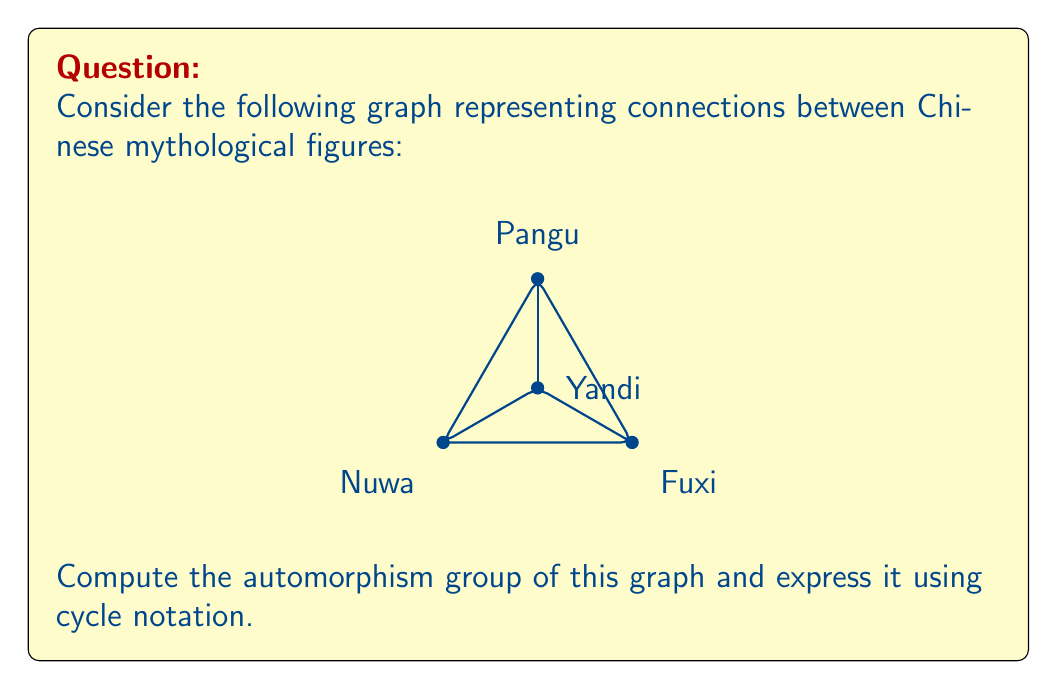Can you answer this question? To find the automorphisms of this graph, we need to identify the permutations of vertices that preserve the edge structure. Let's approach this step-by-step:

1) First, observe that the graph has a symmetry axis through the vertex Yandi (D). This suggests there might be an automorphism swapping Nuwa (A) and Fuxi (B).

2) The degrees of the vertices are:
   Nuwa (A): 3
   Fuxi (B): 3
   Pangu (C): 3
   Yandi (D): 3

   All vertices have the same degree, so we can't distinguish them based on degree alone.

3) However, notice that Pangu (C) is the only vertex connected to all other vertices. This means Pangu must map to itself in any automorphism.

4) Yandi (D) is connected to all vertices except itself. It must also map to itself in any automorphism.

5) The only possible non-trivial automorphism is swapping Nuwa (A) and Fuxi (B), while keeping Pangu (C) and Yandi (D) fixed.

6) Therefore, the automorphism group consists of two permutations:
   - The identity permutation: $(A)(B)(C)(D)$
   - The permutation swapping A and B: $(AB)(C)(D)$

7) This group is isomorphic to $\mathbb{Z}_2$, the cyclic group of order 2.
Answer: $\{(A)(B)(C)(D), (AB)(C)(D)\}$ 